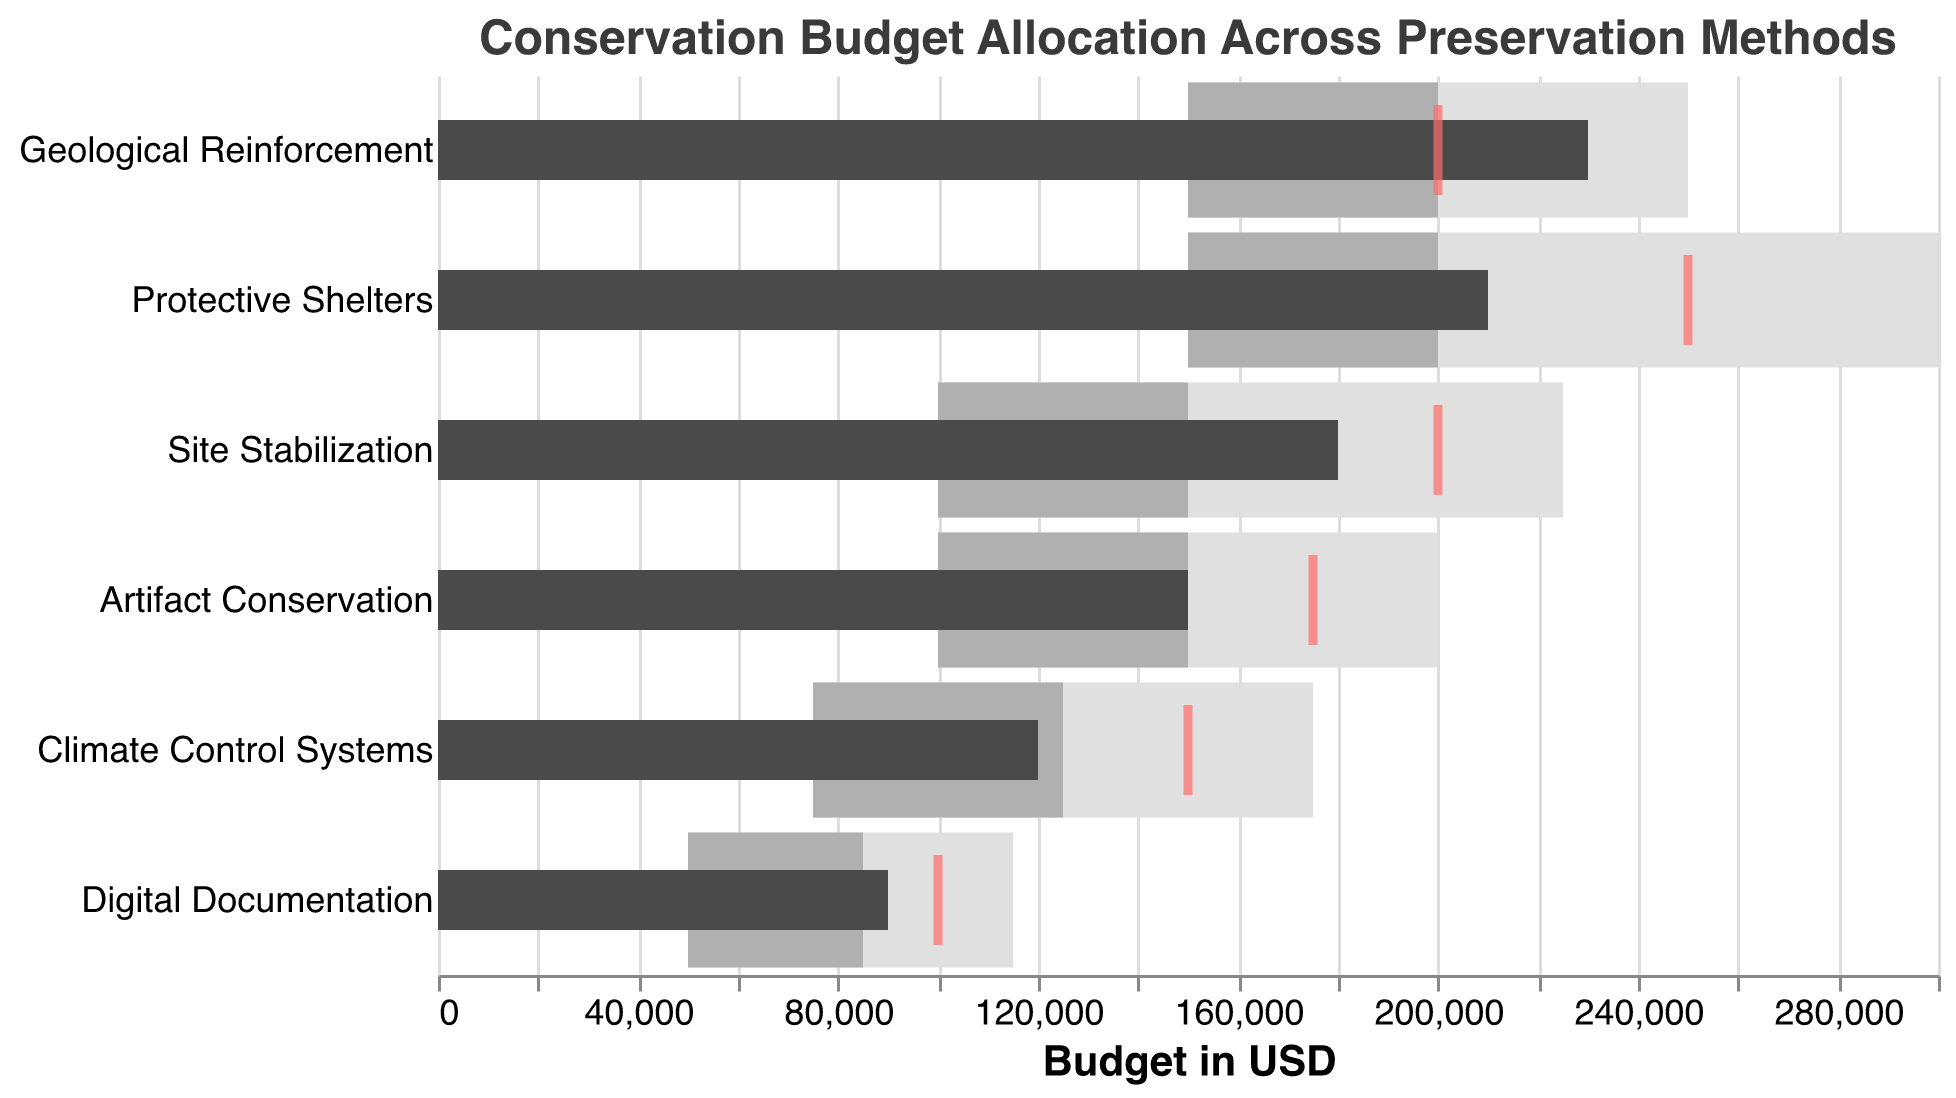What is the title of the chart? It is at the top of the visual and often highlights the theme or main subject of the chart: "Conservation Budget Allocation Across Preservation Methods."
Answer: Conservation Budget Allocation Across Preservation Methods Which preservation method has the highest actual budget? Inspect the "Actual" bars for each method and identify the tallest one. Geological Reinforcement has an "Actual" budget of 230000, the highest among all methods listed.
Answer: Geological Reinforcement What is the target budget for Digital Documentation? Look at the red tick marks for the "Digital Documentation" row. The target value there is 100000.
Answer: 100000 Is the actual budget for Climate Control Systems above or below its target? Compare the black bar (actual) and the red tick mark (target) for Climate Control Systems. The actual value (120000) is below the target value (150000).
Answer: Below What are the budget ranges for Protective Shelters? The ranges indicated by bars are from 150000 to 200000 (medium grey), and from 200000 to 300000 (light grey).
Answer: 150000 to 300000 How does the actual budget for Site Stabilization compare with its highest range value? Compare the "Actual" value (180000) for Site Stabilization with its highest range value (225000). The actual value is below the highest range value.
Answer: Below Which methods have actual budgets exceeding their target budgets? Identify methods where the "Actual" bar exceeds the red tick mark. Geological Reinforcement (230000 vs. 200000) is above its target.
Answer: Geological Reinforcement What's the difference between the actual and target budgets for Artifact Conservation? Subtract the actual value from the target value for Artifact Conservation: \( 175000 - 150000 = 25000 \).
Answer: 25000 What preservation method has the widest budget range from Range1 to Range3? Subtract Range1 from Range3 for each method and compare. Protective Shelters has the widest range: \( 300000 - 150000 = 150000 \).
Answer: Protective Shelters 